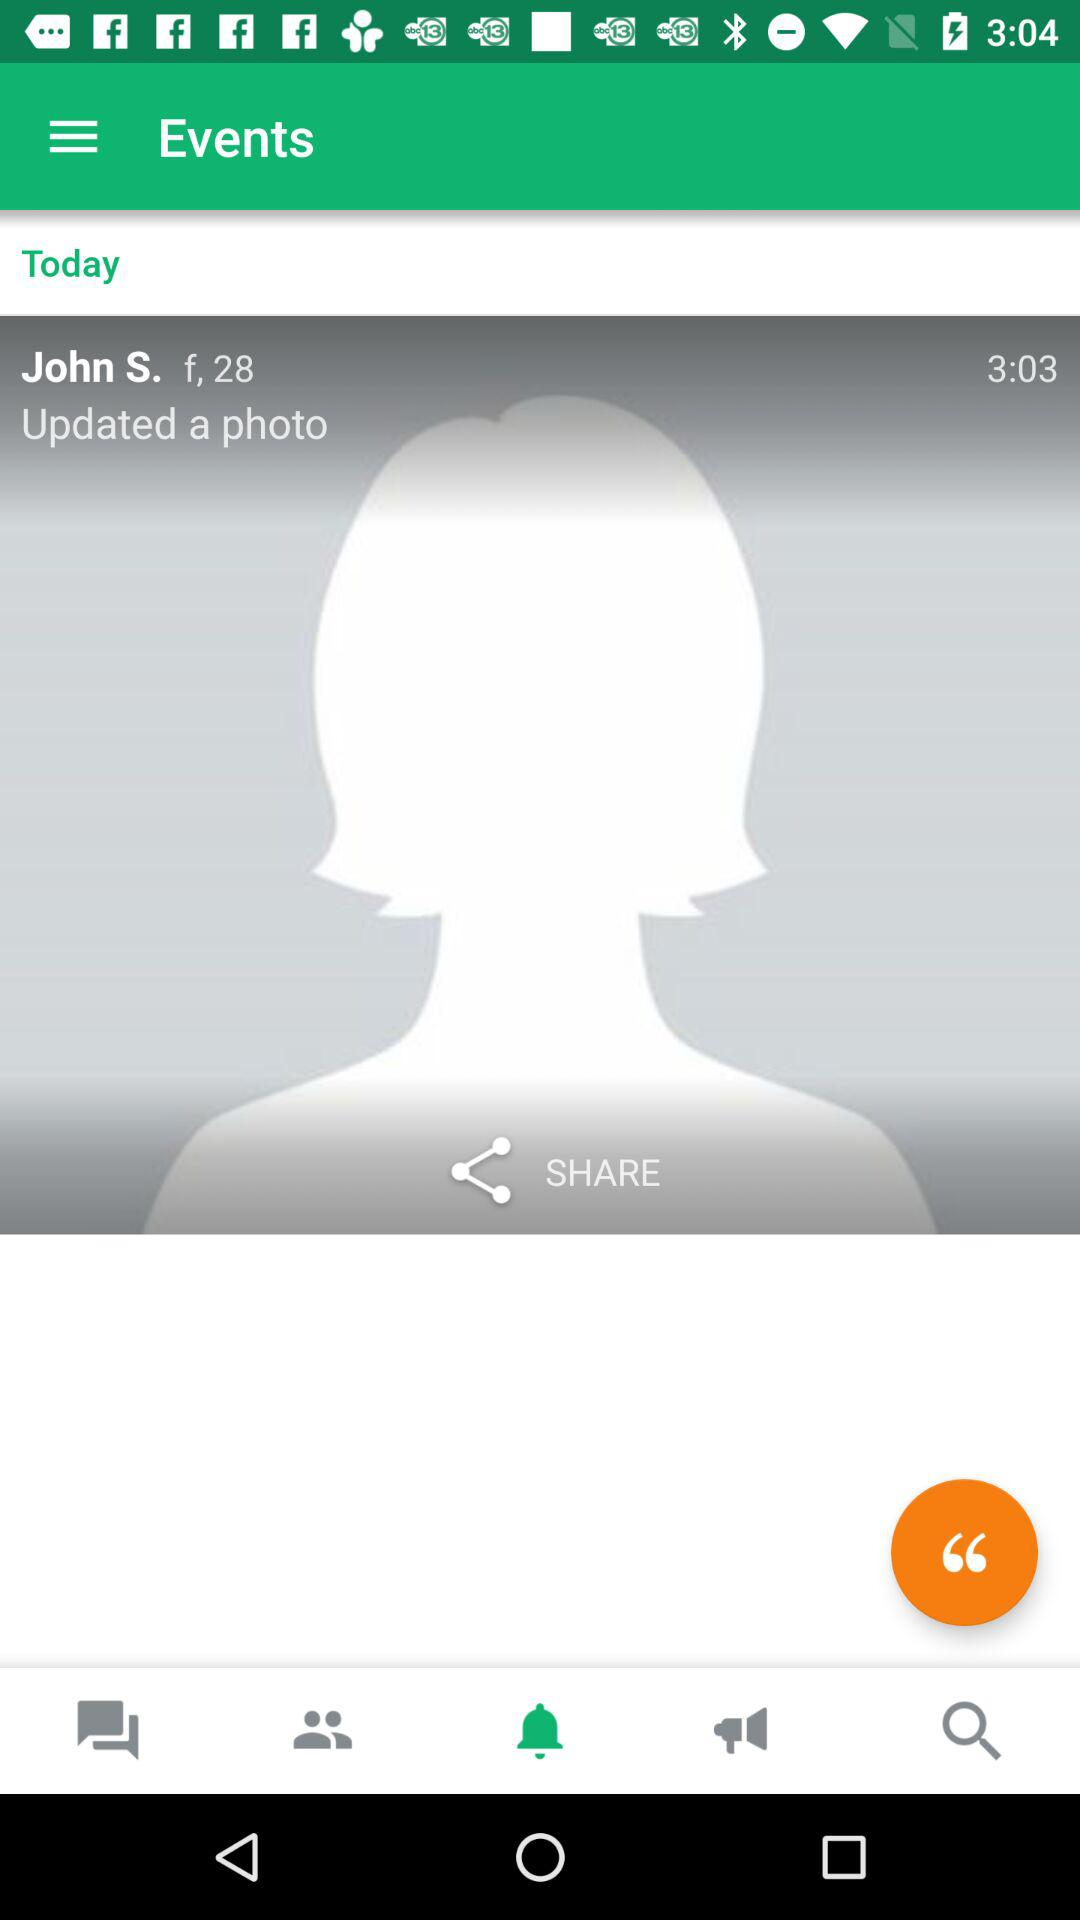What is the age of the user? The user is 28 years old. 